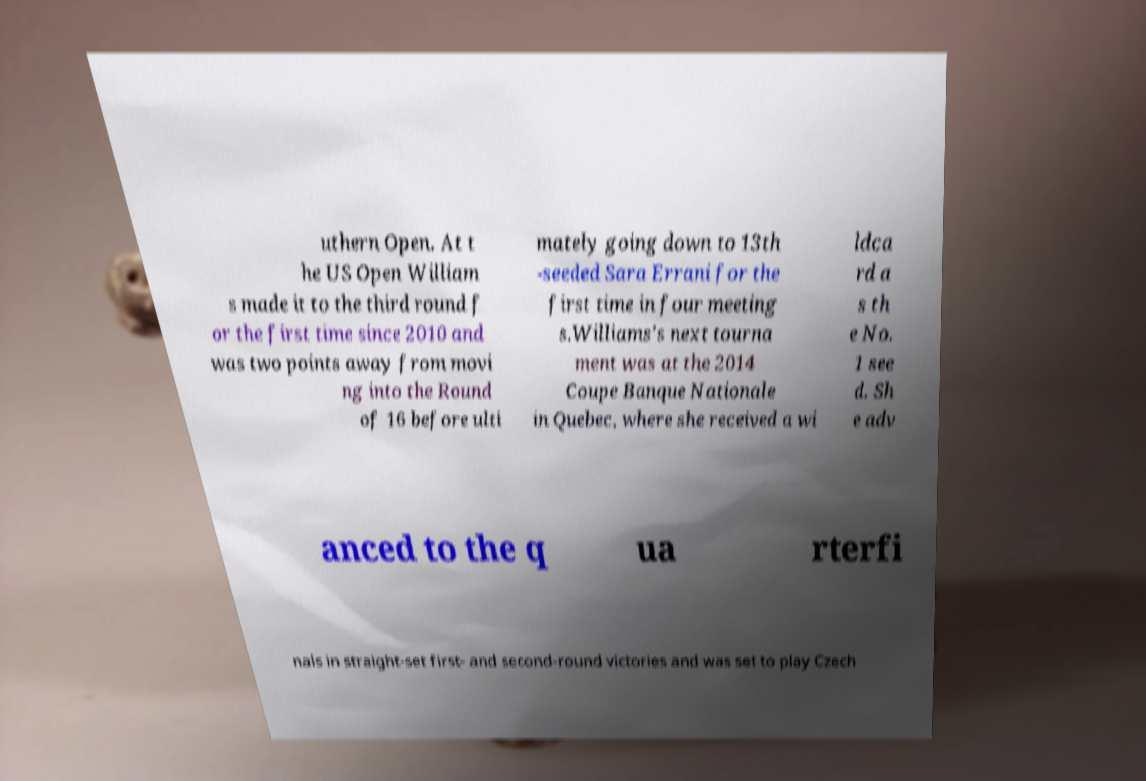Can you accurately transcribe the text from the provided image for me? uthern Open. At t he US Open William s made it to the third round f or the first time since 2010 and was two points away from movi ng into the Round of 16 before ulti mately going down to 13th -seeded Sara Errani for the first time in four meeting s.Williams's next tourna ment was at the 2014 Coupe Banque Nationale in Quebec, where she received a wi ldca rd a s th e No. 1 see d. Sh e adv anced to the q ua rterfi nals in straight-set first- and second-round victories and was set to play Czech 